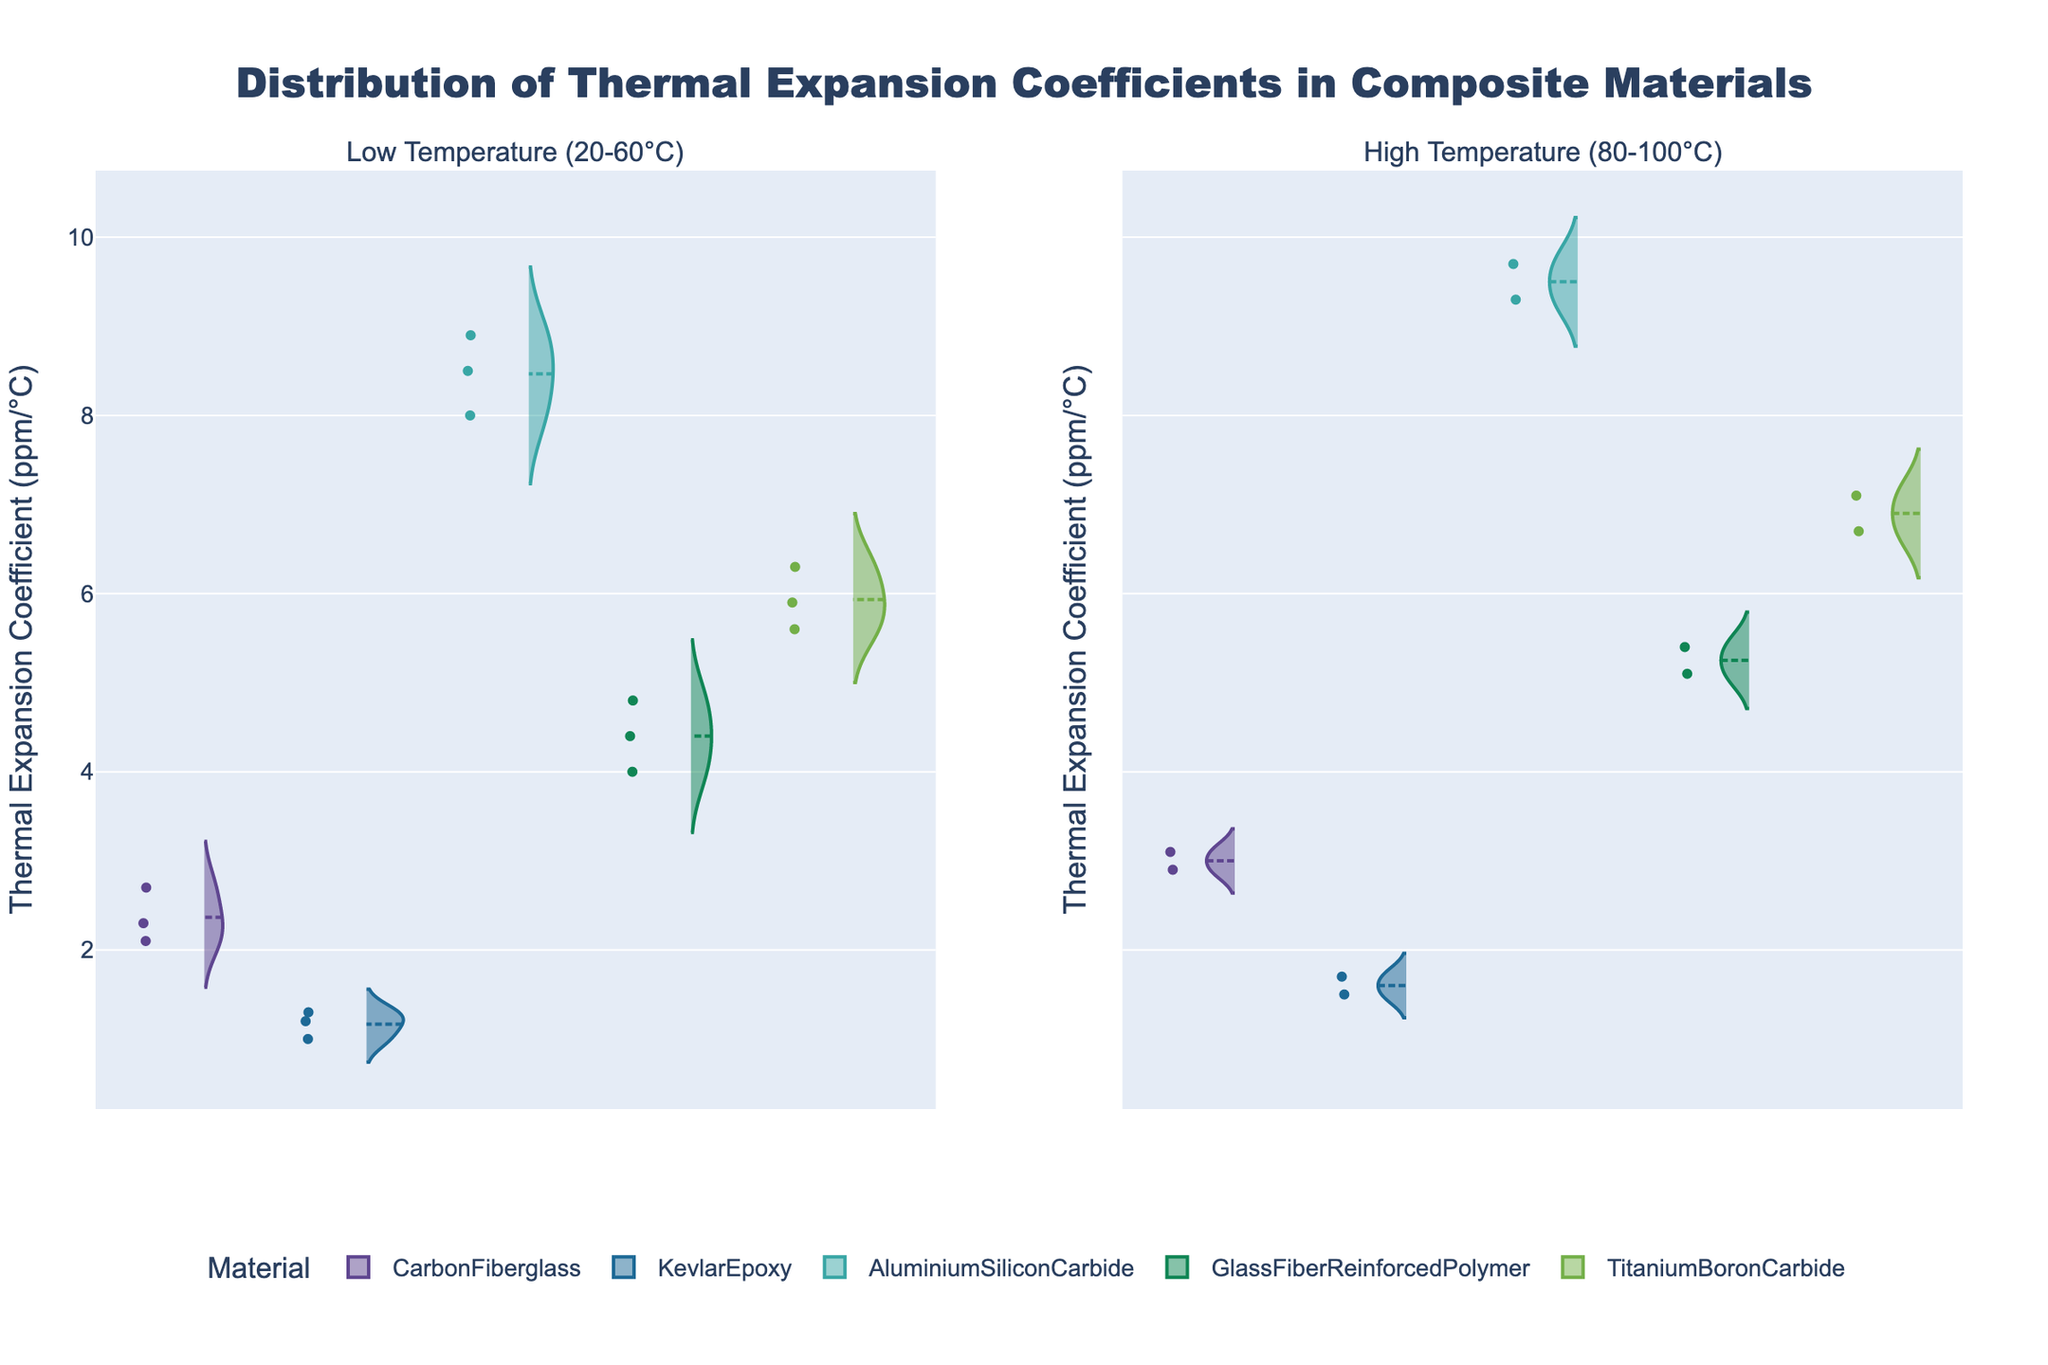How many composite materials are shown in the figure? The figure displays viollin plots with distinct colors for each material. By counting the different colors/legends, we can identify the number of composite materials.
Answer: 5 What is the title of the figure? The title is clearly displayed at the top of the figure.
Answer: Distribution of Thermal Expansion Coefficients in Composite Materials Which material has the highest distribution of thermal expansion coefficients at high temperatures? Look at the high temperature subplot (80-100°C) and identify the material whose violin plot extends the furthest on the negative side. This shows the material with the highest distribution.
Answer: AluminiumSiliconCarbide What is the mean thermal expansion coefficient of KevlarEpoxy at low temperatures? Find the mean line within the KevlarEpoxy violin plot in the low-temperature subplot. The mean line is usually a visible point or line within each violin plot.
Answer: 1.166 ppm/°C Which composite material shows the smallest spread in its thermal expansion coefficients at low temperatures? For low temperatures (20-60°C), observe the width of each violin plot. The material with the narrowest plot indicates the smallest spread.
Answer: KevlarEpoxy Compare the thermal expansion coefficients of CarbonFiberglass and GlassFiberReinforcedPolymer at low temperatures. Which one tends to be higher? Examine the violin plots of both materials in the low-temperature subplot. The material with the higher central tendency (mean line) and wider distribution towards higher values tends to have higher coefficients.
Answer: CarbonFiberglass What can you say about the distribution of TitaniumBoronCarbide's thermal expansion coefficients across both temperature ranges? Compare the violin plots of TitaniumBoronCarbide in both subplots. Look at the spread, central tendency (mean lines), and any overlaps or distinctions.
Answer: The distributions shift higher as temperature increases How does the mean thermal expansion coefficient of AluminiumSiliconCarbide change from low to high temperatures? Identify the mean lines for AluminiumSiliconCarbide in both subplots. Compare the positions of these lines from the low-temperature to the high-temperature subplot.
Answer: It increases Which two materials have the most similar thermal expansion coefficients at low temperatures? Analyze the violin plots in the low-temperature subplot and find the two plots that are most closely aligned in terms of their average and spread.
Answer: TitanBoronCarbide and GlassFiberReinforcedPolymer 